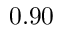Convert formula to latex. <formula><loc_0><loc_0><loc_500><loc_500>0 . 9 0</formula> 